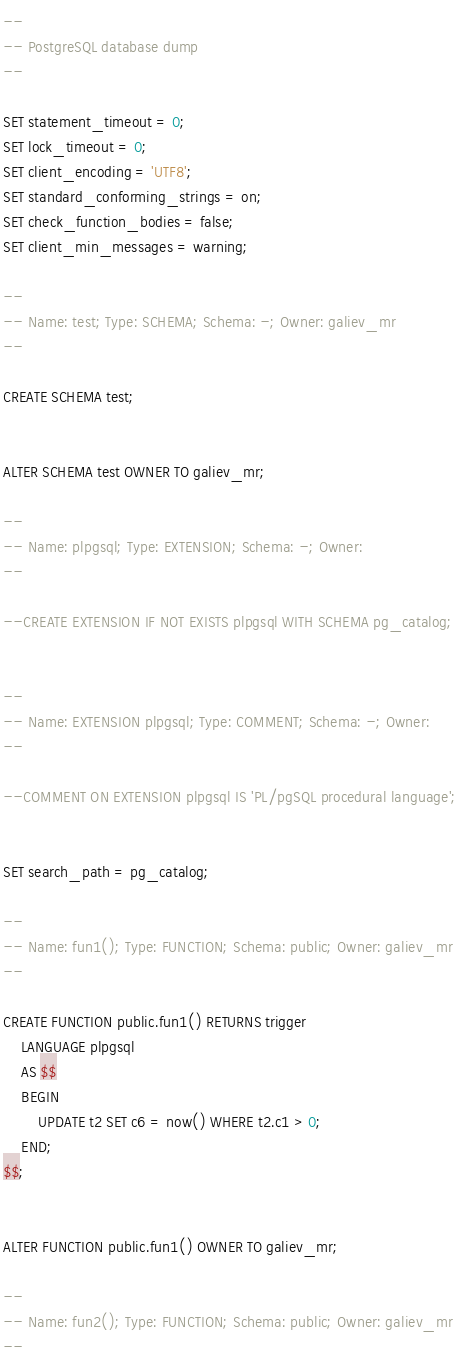Convert code to text. <code><loc_0><loc_0><loc_500><loc_500><_SQL_>--
-- PostgreSQL database dump
--

SET statement_timeout = 0;
SET lock_timeout = 0;
SET client_encoding = 'UTF8';
SET standard_conforming_strings = on;
SET check_function_bodies = false;
SET client_min_messages = warning;

--
-- Name: test; Type: SCHEMA; Schema: -; Owner: galiev_mr
--

CREATE SCHEMA test;


ALTER SCHEMA test OWNER TO galiev_mr;

--
-- Name: plpgsql; Type: EXTENSION; Schema: -; Owner: 
--

--CREATE EXTENSION IF NOT EXISTS plpgsql WITH SCHEMA pg_catalog;


--
-- Name: EXTENSION plpgsql; Type: COMMENT; Schema: -; Owner: 
--

--COMMENT ON EXTENSION plpgsql IS 'PL/pgSQL procedural language';


SET search_path = pg_catalog;

--
-- Name: fun1(); Type: FUNCTION; Schema: public; Owner: galiev_mr
--

CREATE FUNCTION public.fun1() RETURNS trigger
    LANGUAGE plpgsql
    AS $$
    BEGIN
        UPDATE t2 SET c6 = now() WHERE t2.c1 > 0;
    END;
$$;


ALTER FUNCTION public.fun1() OWNER TO galiev_mr;

--
-- Name: fun2(); Type: FUNCTION; Schema: public; Owner: galiev_mr
--
</code> 